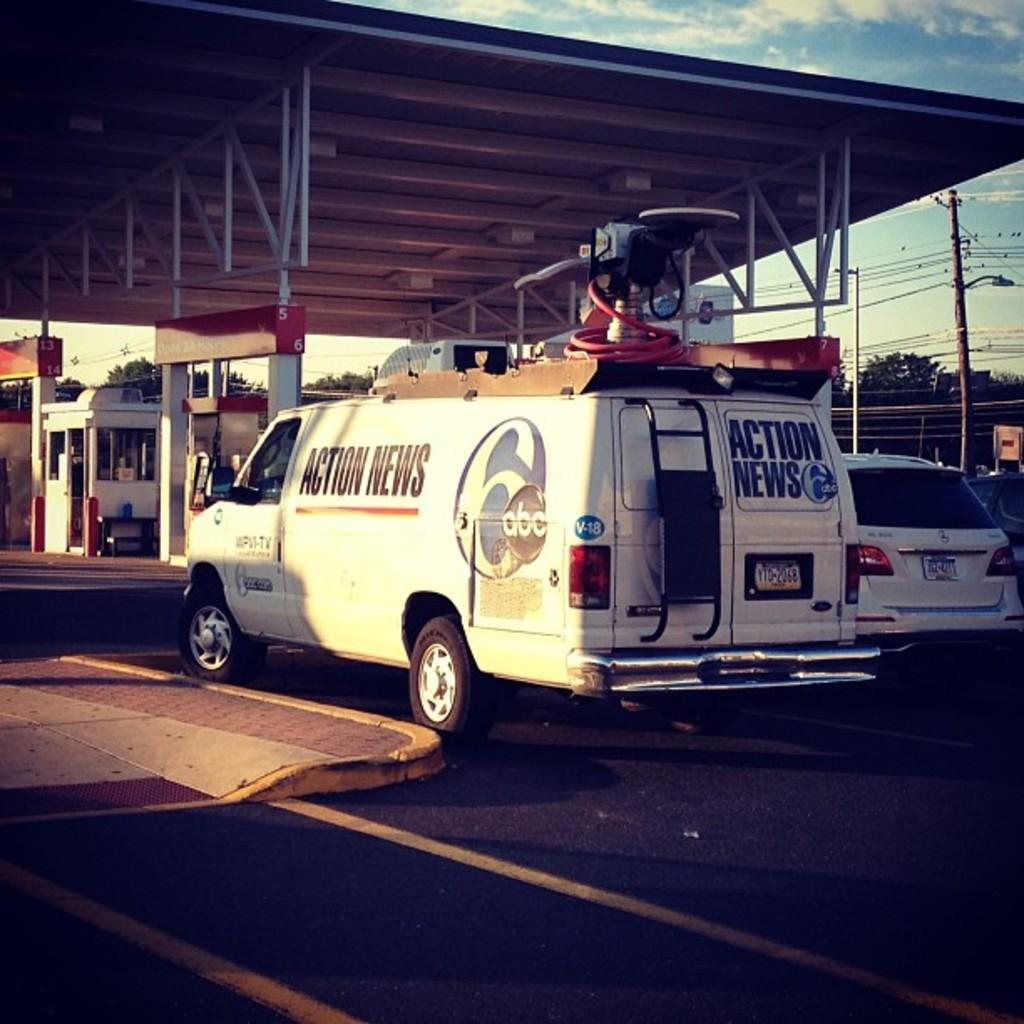<image>
Summarize the visual content of the image. An Action News van that works for abc affiliate channel 6. 